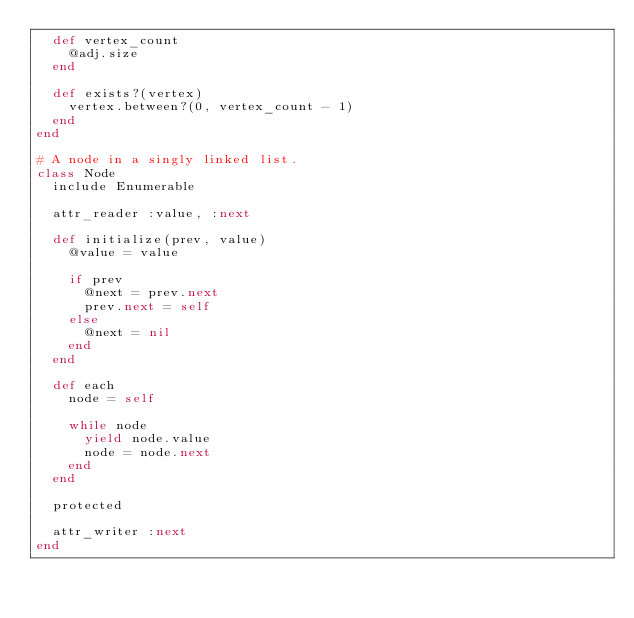Convert code to text. <code><loc_0><loc_0><loc_500><loc_500><_Ruby_>  def vertex_count
    @adj.size
  end

  def exists?(vertex)
    vertex.between?(0, vertex_count - 1)
  end
end

# A node in a singly linked list.
class Node
  include Enumerable

  attr_reader :value, :next

  def initialize(prev, value)
    @value = value

    if prev
      @next = prev.next
      prev.next = self
    else
      @next = nil
    end
  end

  def each
    node = self

    while node
      yield node.value
      node = node.next
    end
  end

  protected

  attr_writer :next
end
</code> 